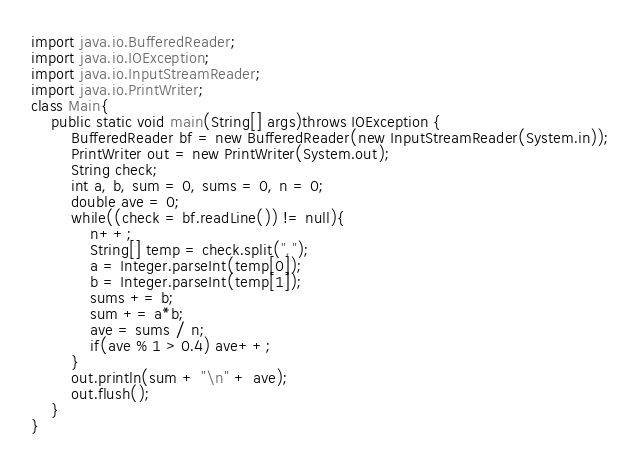<code> <loc_0><loc_0><loc_500><loc_500><_Java_>import java.io.BufferedReader;
import java.io.IOException;
import java.io.InputStreamReader;
import java.io.PrintWriter;
class Main{
	public static void main(String[] args)throws IOException {
		BufferedReader bf = new BufferedReader(new InputStreamReader(System.in));
		PrintWriter out = new PrintWriter(System.out);
		String check;
		int a, b, sum = 0, sums = 0, n = 0;
		double ave = 0;
		while((check = bf.readLine()) != null){
			n++;
			String[] temp = check.split(",");
			a = Integer.parseInt(temp[0]);
			b = Integer.parseInt(temp[1]);
			sums += b;
			sum += a*b;
			ave = sums / n;
			if(ave % 1 > 0.4) ave++;
		}
		out.println(sum + "\n" + ave);
		out.flush();
	}
}</code> 